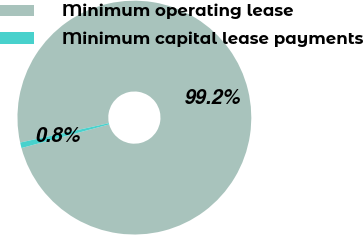Convert chart. <chart><loc_0><loc_0><loc_500><loc_500><pie_chart><fcel>Minimum operating lease<fcel>Minimum capital lease payments<nl><fcel>99.23%<fcel>0.77%<nl></chart> 